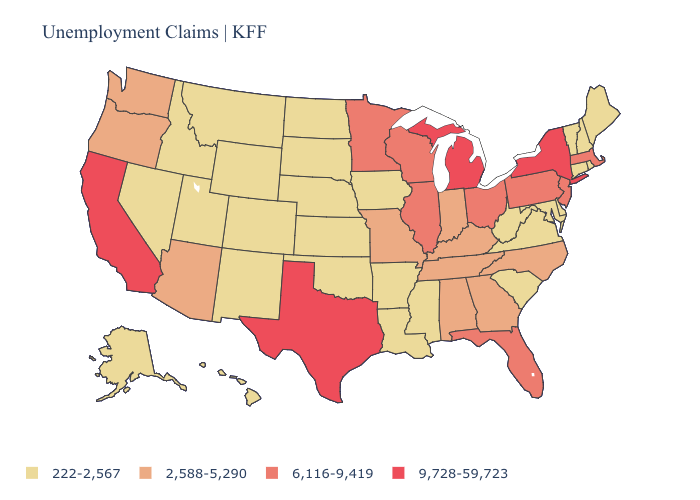Among the states that border Texas , which have the highest value?
Write a very short answer. Arkansas, Louisiana, New Mexico, Oklahoma. Which states have the lowest value in the USA?
Answer briefly. Alaska, Arkansas, Colorado, Connecticut, Delaware, Hawaii, Idaho, Iowa, Kansas, Louisiana, Maine, Maryland, Mississippi, Montana, Nebraska, Nevada, New Hampshire, New Mexico, North Dakota, Oklahoma, Rhode Island, South Carolina, South Dakota, Utah, Vermont, Virginia, West Virginia, Wyoming. Does Maine have the highest value in the Northeast?
Quick response, please. No. What is the value of Idaho?
Give a very brief answer. 222-2,567. Name the states that have a value in the range 9,728-59,723?
Answer briefly. California, Michigan, New York, Texas. Name the states that have a value in the range 9,728-59,723?
Answer briefly. California, Michigan, New York, Texas. Which states have the highest value in the USA?
Quick response, please. California, Michigan, New York, Texas. What is the lowest value in the USA?
Short answer required. 222-2,567. What is the lowest value in states that border Rhode Island?
Write a very short answer. 222-2,567. Among the states that border Pennsylvania , which have the lowest value?
Answer briefly. Delaware, Maryland, West Virginia. Which states have the lowest value in the USA?
Answer briefly. Alaska, Arkansas, Colorado, Connecticut, Delaware, Hawaii, Idaho, Iowa, Kansas, Louisiana, Maine, Maryland, Mississippi, Montana, Nebraska, Nevada, New Hampshire, New Mexico, North Dakota, Oklahoma, Rhode Island, South Carolina, South Dakota, Utah, Vermont, Virginia, West Virginia, Wyoming. Does Wisconsin have the same value as Illinois?
Give a very brief answer. Yes. Does the first symbol in the legend represent the smallest category?
Short answer required. Yes. Does Utah have the lowest value in the West?
Quick response, please. Yes. 